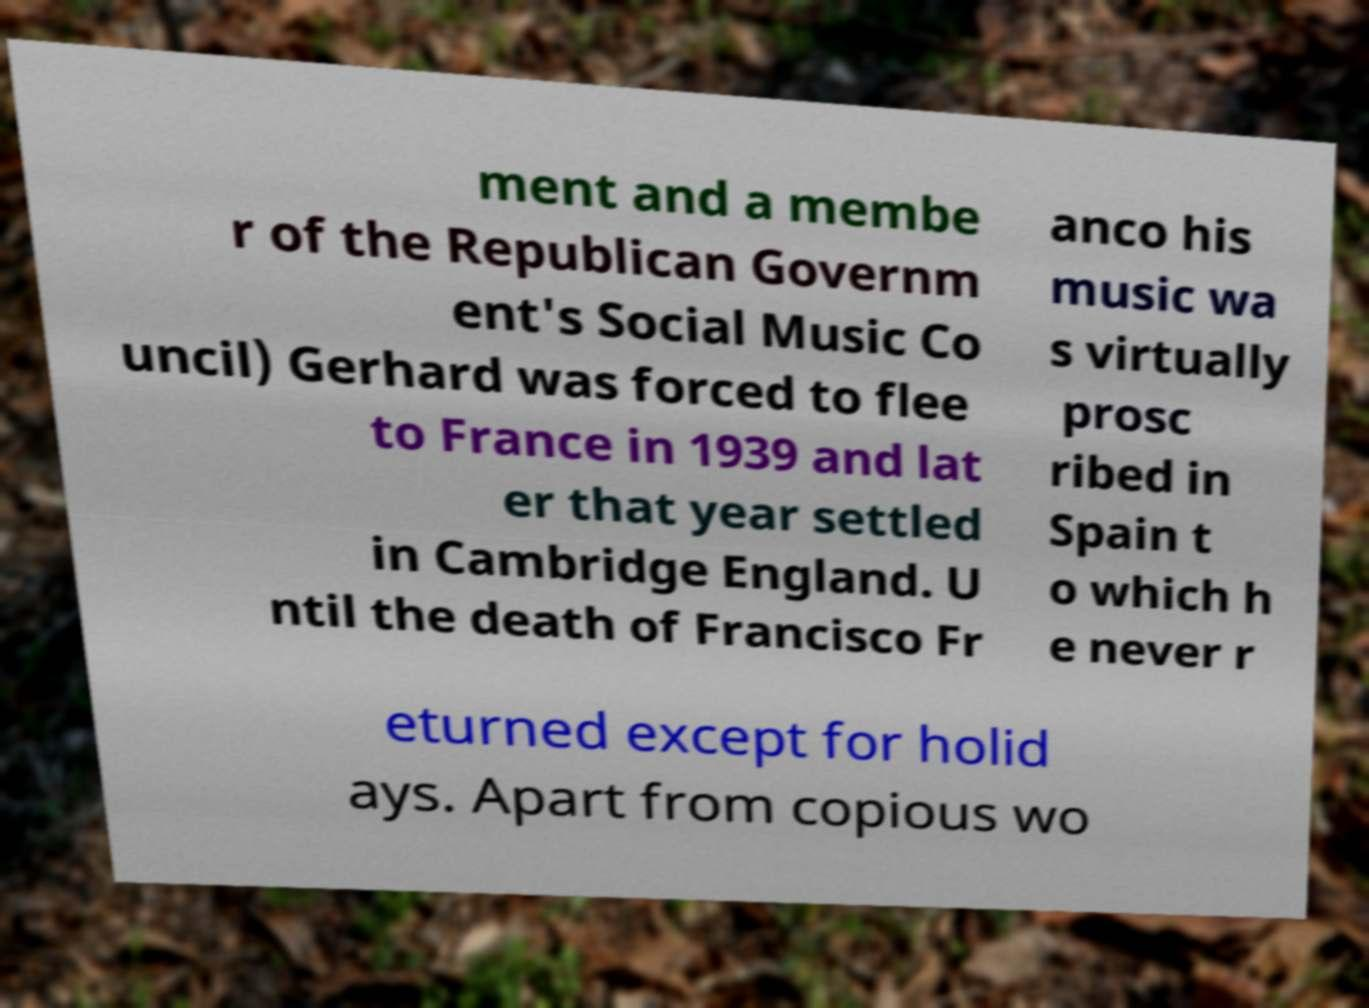I need the written content from this picture converted into text. Can you do that? ment and a membe r of the Republican Governm ent's Social Music Co uncil) Gerhard was forced to flee to France in 1939 and lat er that year settled in Cambridge England. U ntil the death of Francisco Fr anco his music wa s virtually prosc ribed in Spain t o which h e never r eturned except for holid ays. Apart from copious wo 